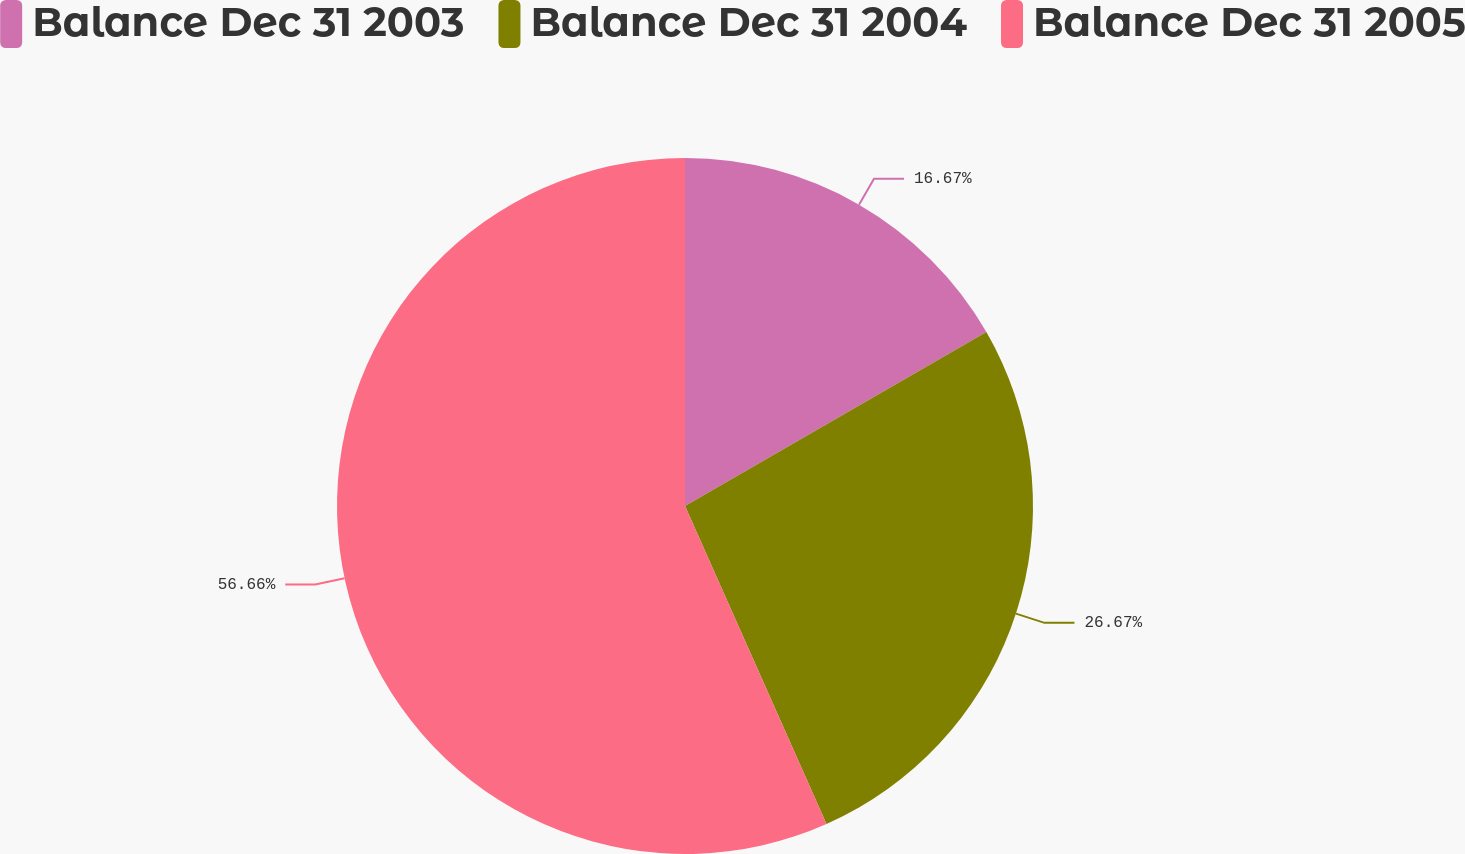Convert chart to OTSL. <chart><loc_0><loc_0><loc_500><loc_500><pie_chart><fcel>Balance Dec 31 2003<fcel>Balance Dec 31 2004<fcel>Balance Dec 31 2005<nl><fcel>16.67%<fcel>26.67%<fcel>56.67%<nl></chart> 